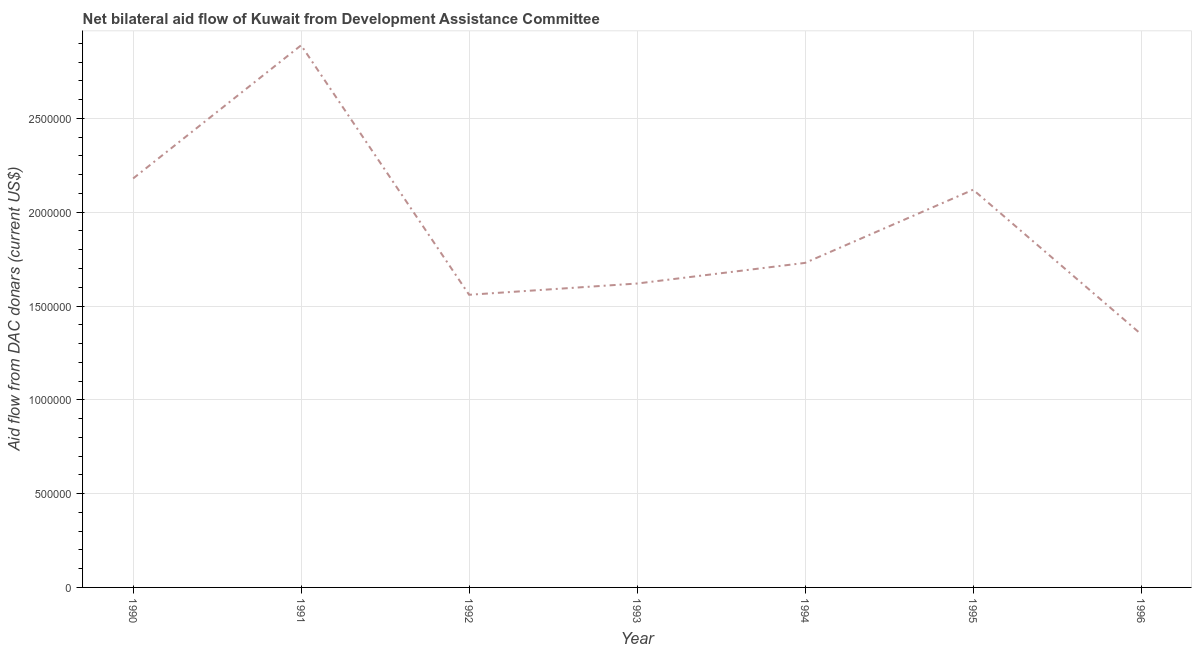What is the net bilateral aid flows from dac donors in 1995?
Offer a very short reply. 2.12e+06. Across all years, what is the maximum net bilateral aid flows from dac donors?
Your answer should be very brief. 2.89e+06. Across all years, what is the minimum net bilateral aid flows from dac donors?
Your answer should be very brief. 1.35e+06. In which year was the net bilateral aid flows from dac donors minimum?
Your answer should be compact. 1996. What is the sum of the net bilateral aid flows from dac donors?
Provide a succinct answer. 1.34e+07. What is the difference between the net bilateral aid flows from dac donors in 1995 and 1996?
Ensure brevity in your answer.  7.70e+05. What is the average net bilateral aid flows from dac donors per year?
Ensure brevity in your answer.  1.92e+06. What is the median net bilateral aid flows from dac donors?
Keep it short and to the point. 1.73e+06. In how many years, is the net bilateral aid flows from dac donors greater than 600000 US$?
Give a very brief answer. 7. What is the ratio of the net bilateral aid flows from dac donors in 1991 to that in 1996?
Provide a succinct answer. 2.14. Is the difference between the net bilateral aid flows from dac donors in 1990 and 1995 greater than the difference between any two years?
Your response must be concise. No. What is the difference between the highest and the second highest net bilateral aid flows from dac donors?
Make the answer very short. 7.10e+05. Is the sum of the net bilateral aid flows from dac donors in 1993 and 1996 greater than the maximum net bilateral aid flows from dac donors across all years?
Provide a succinct answer. Yes. What is the difference between the highest and the lowest net bilateral aid flows from dac donors?
Provide a succinct answer. 1.54e+06. What is the difference between two consecutive major ticks on the Y-axis?
Your answer should be very brief. 5.00e+05. Are the values on the major ticks of Y-axis written in scientific E-notation?
Provide a succinct answer. No. Does the graph contain any zero values?
Offer a very short reply. No. Does the graph contain grids?
Your answer should be compact. Yes. What is the title of the graph?
Keep it short and to the point. Net bilateral aid flow of Kuwait from Development Assistance Committee. What is the label or title of the X-axis?
Keep it short and to the point. Year. What is the label or title of the Y-axis?
Provide a succinct answer. Aid flow from DAC donars (current US$). What is the Aid flow from DAC donars (current US$) in 1990?
Ensure brevity in your answer.  2.18e+06. What is the Aid flow from DAC donars (current US$) in 1991?
Provide a short and direct response. 2.89e+06. What is the Aid flow from DAC donars (current US$) in 1992?
Provide a succinct answer. 1.56e+06. What is the Aid flow from DAC donars (current US$) of 1993?
Your answer should be compact. 1.62e+06. What is the Aid flow from DAC donars (current US$) of 1994?
Make the answer very short. 1.73e+06. What is the Aid flow from DAC donars (current US$) in 1995?
Your answer should be very brief. 2.12e+06. What is the Aid flow from DAC donars (current US$) in 1996?
Ensure brevity in your answer.  1.35e+06. What is the difference between the Aid flow from DAC donars (current US$) in 1990 and 1991?
Make the answer very short. -7.10e+05. What is the difference between the Aid flow from DAC donars (current US$) in 1990 and 1992?
Offer a very short reply. 6.20e+05. What is the difference between the Aid flow from DAC donars (current US$) in 1990 and 1993?
Ensure brevity in your answer.  5.60e+05. What is the difference between the Aid flow from DAC donars (current US$) in 1990 and 1995?
Offer a very short reply. 6.00e+04. What is the difference between the Aid flow from DAC donars (current US$) in 1990 and 1996?
Provide a succinct answer. 8.30e+05. What is the difference between the Aid flow from DAC donars (current US$) in 1991 and 1992?
Make the answer very short. 1.33e+06. What is the difference between the Aid flow from DAC donars (current US$) in 1991 and 1993?
Your response must be concise. 1.27e+06. What is the difference between the Aid flow from DAC donars (current US$) in 1991 and 1994?
Make the answer very short. 1.16e+06. What is the difference between the Aid flow from DAC donars (current US$) in 1991 and 1995?
Ensure brevity in your answer.  7.70e+05. What is the difference between the Aid flow from DAC donars (current US$) in 1991 and 1996?
Offer a terse response. 1.54e+06. What is the difference between the Aid flow from DAC donars (current US$) in 1992 and 1995?
Your response must be concise. -5.60e+05. What is the difference between the Aid flow from DAC donars (current US$) in 1993 and 1995?
Give a very brief answer. -5.00e+05. What is the difference between the Aid flow from DAC donars (current US$) in 1993 and 1996?
Provide a succinct answer. 2.70e+05. What is the difference between the Aid flow from DAC donars (current US$) in 1994 and 1995?
Offer a terse response. -3.90e+05. What is the difference between the Aid flow from DAC donars (current US$) in 1995 and 1996?
Offer a terse response. 7.70e+05. What is the ratio of the Aid flow from DAC donars (current US$) in 1990 to that in 1991?
Ensure brevity in your answer.  0.75. What is the ratio of the Aid flow from DAC donars (current US$) in 1990 to that in 1992?
Offer a terse response. 1.4. What is the ratio of the Aid flow from DAC donars (current US$) in 1990 to that in 1993?
Offer a terse response. 1.35. What is the ratio of the Aid flow from DAC donars (current US$) in 1990 to that in 1994?
Give a very brief answer. 1.26. What is the ratio of the Aid flow from DAC donars (current US$) in 1990 to that in 1995?
Ensure brevity in your answer.  1.03. What is the ratio of the Aid flow from DAC donars (current US$) in 1990 to that in 1996?
Give a very brief answer. 1.61. What is the ratio of the Aid flow from DAC donars (current US$) in 1991 to that in 1992?
Offer a very short reply. 1.85. What is the ratio of the Aid flow from DAC donars (current US$) in 1991 to that in 1993?
Keep it short and to the point. 1.78. What is the ratio of the Aid flow from DAC donars (current US$) in 1991 to that in 1994?
Provide a succinct answer. 1.67. What is the ratio of the Aid flow from DAC donars (current US$) in 1991 to that in 1995?
Ensure brevity in your answer.  1.36. What is the ratio of the Aid flow from DAC donars (current US$) in 1991 to that in 1996?
Offer a very short reply. 2.14. What is the ratio of the Aid flow from DAC donars (current US$) in 1992 to that in 1994?
Your answer should be compact. 0.9. What is the ratio of the Aid flow from DAC donars (current US$) in 1992 to that in 1995?
Provide a succinct answer. 0.74. What is the ratio of the Aid flow from DAC donars (current US$) in 1992 to that in 1996?
Your answer should be compact. 1.16. What is the ratio of the Aid flow from DAC donars (current US$) in 1993 to that in 1994?
Give a very brief answer. 0.94. What is the ratio of the Aid flow from DAC donars (current US$) in 1993 to that in 1995?
Make the answer very short. 0.76. What is the ratio of the Aid flow from DAC donars (current US$) in 1993 to that in 1996?
Offer a very short reply. 1.2. What is the ratio of the Aid flow from DAC donars (current US$) in 1994 to that in 1995?
Your answer should be very brief. 0.82. What is the ratio of the Aid flow from DAC donars (current US$) in 1994 to that in 1996?
Ensure brevity in your answer.  1.28. What is the ratio of the Aid flow from DAC donars (current US$) in 1995 to that in 1996?
Ensure brevity in your answer.  1.57. 